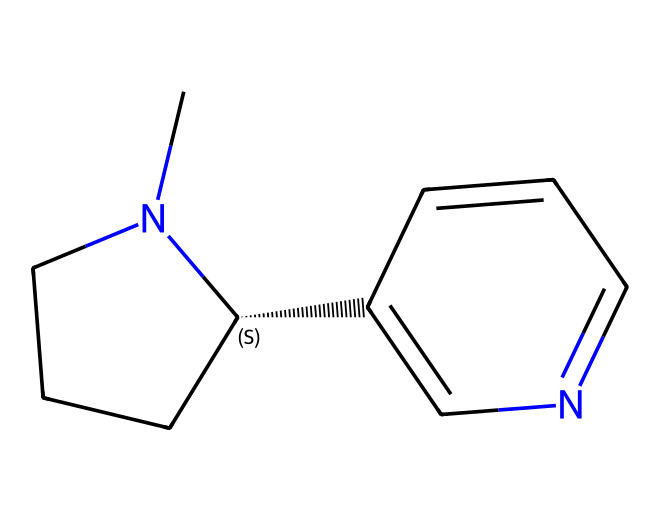How many carbon atoms are in this molecule? By examining the SMILES representation, each "C" represents a carbon atom. Counting all the carbon atoms yields a total of 10 carbon atoms.
Answer: 10 What functional group is present in this chemical? The presence of a nitrogen atom in the structure (indicated by "N") suggests it contains an amine functional group.
Answer: amine Is this molecule likely to be polar or nonpolar? The structure contains both carbon and nitrogen atoms, and the presence of nitrogen typically increases polarity due to its electronegativity. However, the overall shape is predominantly hydrophobic, indicating it is likely nonpolar.
Answer: nonpolar Does this chemical have a ring structure? The representation includes numbers indicating bonded atoms, which indicates the presence of a ring. This confirms the existence of cyclic structures within the molecule.
Answer: yes What type of solvent would this chemical be classified as? Considering its structure, which includes an amine group and is hydrocarbon-based, it can be categorized as a solvent that is organic and likely has properties suitable for dissolving nonpolar solutes.
Answer: organic solvent What is the approximate molecular weight of this compound? The molecular weight can be calculated by summing the atomic weights of all constituent atoms (C, H, and N). Counting and calculating yields an approximate molecular weight of 162 g/mol.
Answer: 162 g/mol How many rings are present in this chemical structure? The numbering in the SMILES indicates the start and end of a cyclic structure. There is one distinct numbering pair, which signifies one ring in the compound.
Answer: 1 